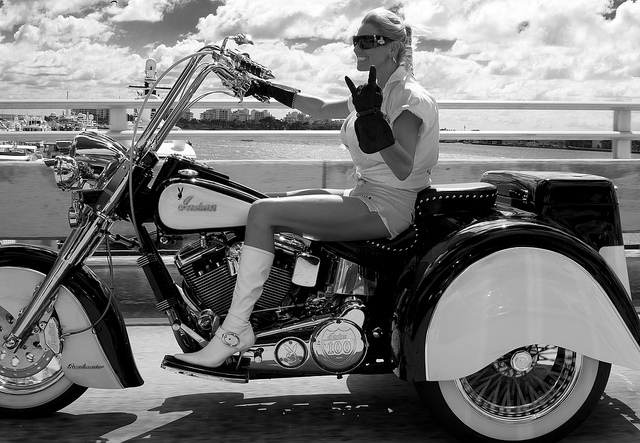Identify the text displayed in this image. 100 